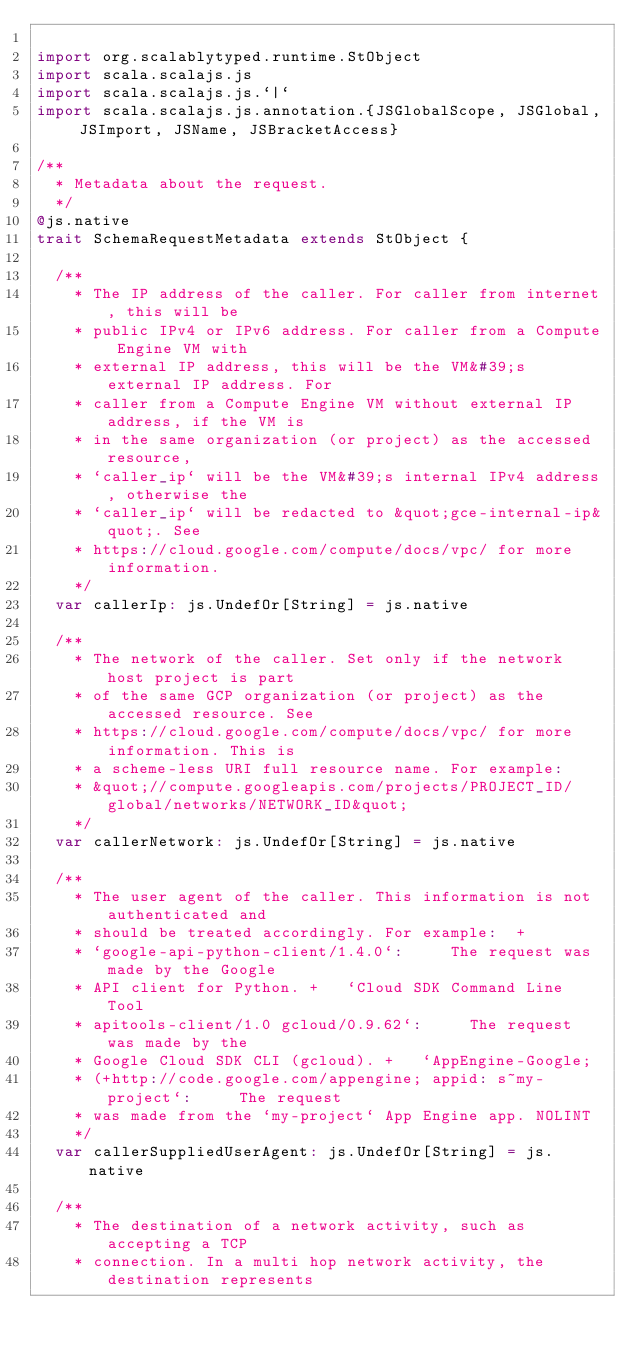<code> <loc_0><loc_0><loc_500><loc_500><_Scala_>
import org.scalablytyped.runtime.StObject
import scala.scalajs.js
import scala.scalajs.js.`|`
import scala.scalajs.js.annotation.{JSGlobalScope, JSGlobal, JSImport, JSName, JSBracketAccess}

/**
  * Metadata about the request.
  */
@js.native
trait SchemaRequestMetadata extends StObject {
  
  /**
    * The IP address of the caller. For caller from internet, this will be
    * public IPv4 or IPv6 address. For caller from a Compute Engine VM with
    * external IP address, this will be the VM&#39;s external IP address. For
    * caller from a Compute Engine VM without external IP address, if the VM is
    * in the same organization (or project) as the accessed resource,
    * `caller_ip` will be the VM&#39;s internal IPv4 address, otherwise the
    * `caller_ip` will be redacted to &quot;gce-internal-ip&quot;. See
    * https://cloud.google.com/compute/docs/vpc/ for more information.
    */
  var callerIp: js.UndefOr[String] = js.native
  
  /**
    * The network of the caller. Set only if the network host project is part
    * of the same GCP organization (or project) as the accessed resource. See
    * https://cloud.google.com/compute/docs/vpc/ for more information. This is
    * a scheme-less URI full resource name. For example:
    * &quot;//compute.googleapis.com/projects/PROJECT_ID/global/networks/NETWORK_ID&quot;
    */
  var callerNetwork: js.UndefOr[String] = js.native
  
  /**
    * The user agent of the caller. This information is not authenticated and
    * should be treated accordingly. For example:  +
    * `google-api-python-client/1.4.0`:     The request was made by the Google
    * API client for Python. +   `Cloud SDK Command Line Tool
    * apitools-client/1.0 gcloud/0.9.62`:     The request was made by the
    * Google Cloud SDK CLI (gcloud). +   `AppEngine-Google;
    * (+http://code.google.com/appengine; appid: s~my-project`:     The request
    * was made from the `my-project` App Engine app. NOLINT
    */
  var callerSuppliedUserAgent: js.UndefOr[String] = js.native
  
  /**
    * The destination of a network activity, such as accepting a TCP
    * connection. In a multi hop network activity, the destination represents</code> 